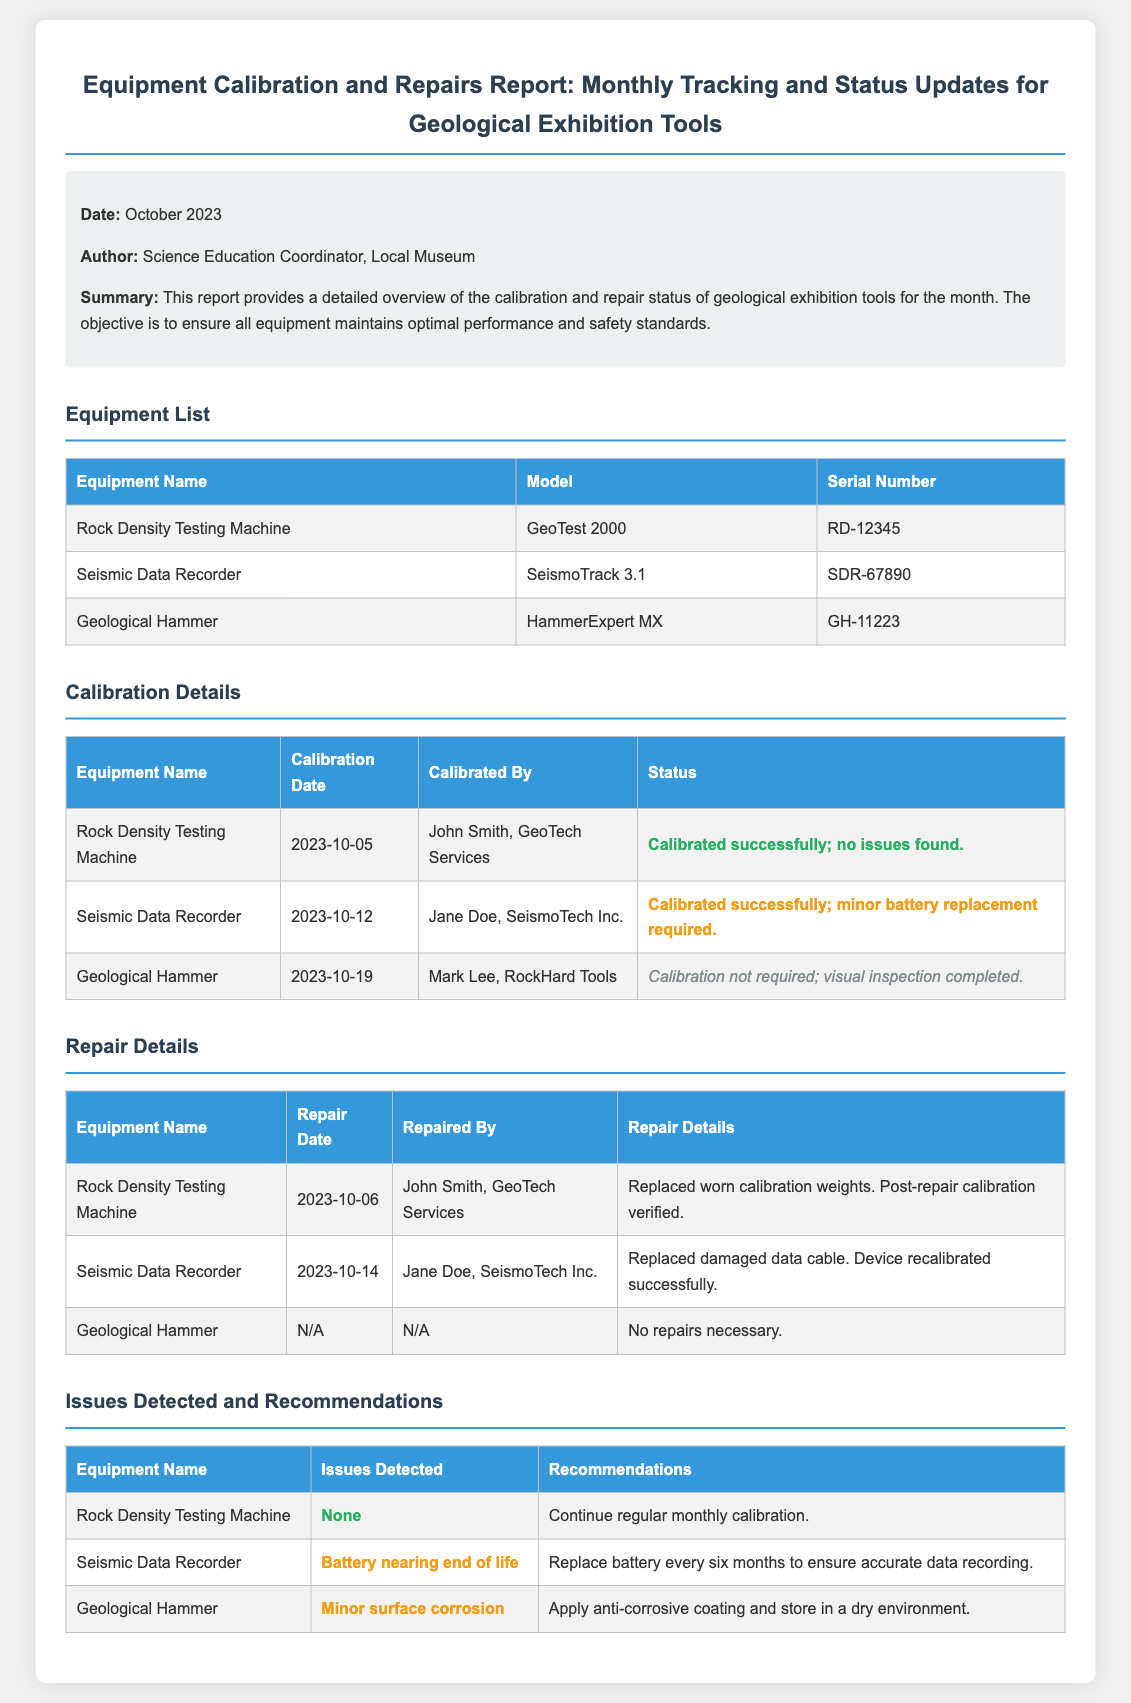What is the calibration date for the Seismic Data Recorder? The calibration date is provided in the Calibration Details section of the document, specifically for the Seismic Data Recorder.
Answer: 2023-10-12 Who calibrated the Geological Hammer? The person who calibrated the Geological Hammer is mentioned under the Calibration Details section.
Answer: Mark Lee, RockHard Tools What repairs were made to the Rock Density Testing Machine? The repairs are listed in the Repair Details section, detailing what was done to the Rock Density Testing Machine.
Answer: Replaced worn calibration weights. Post-repair calibration verified What issue was detected with the Geographical Hammer? The issue detected is noted in the Issues Detected and Recommendations section for the Geographical Hammer.
Answer: Minor surface corrosion What is the recommendation for the Seismic Data Recorder’s battery? The recommendation is stated in the Issues Detected and Recommendations section regarding battery maintenance.
Answer: Replace battery every six months to ensure accurate data recording When was the Rock Density Testing Machine calibrated? The calibration date is listed in the Calibration Details table for the Rock Density Testing Machine.
Answer: 2023-10-05 How many pieces of equipment are listed in the document? The Equipment List section contains the number of pieces of equipment detailed in the document.
Answer: 3 What is the status of the Seismic Data Recorder after calibration? The status is provided in the Calibration Details table for the Seismic Data Recorder.
Answer: Calibrated successfully; minor battery replacement required 